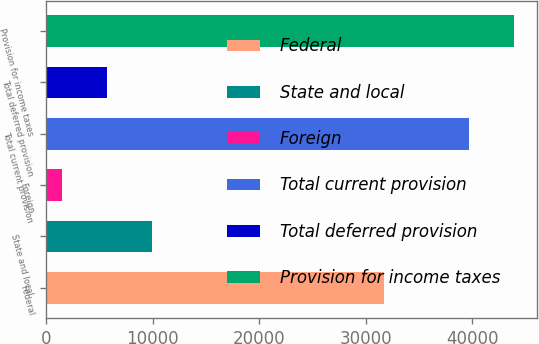<chart> <loc_0><loc_0><loc_500><loc_500><bar_chart><fcel>Federal<fcel>State and local<fcel>Foreign<fcel>Total current provision<fcel>Total deferred provision<fcel>Provision for income taxes<nl><fcel>31700<fcel>9910.8<fcel>1456<fcel>39661<fcel>5683.4<fcel>43888.4<nl></chart> 